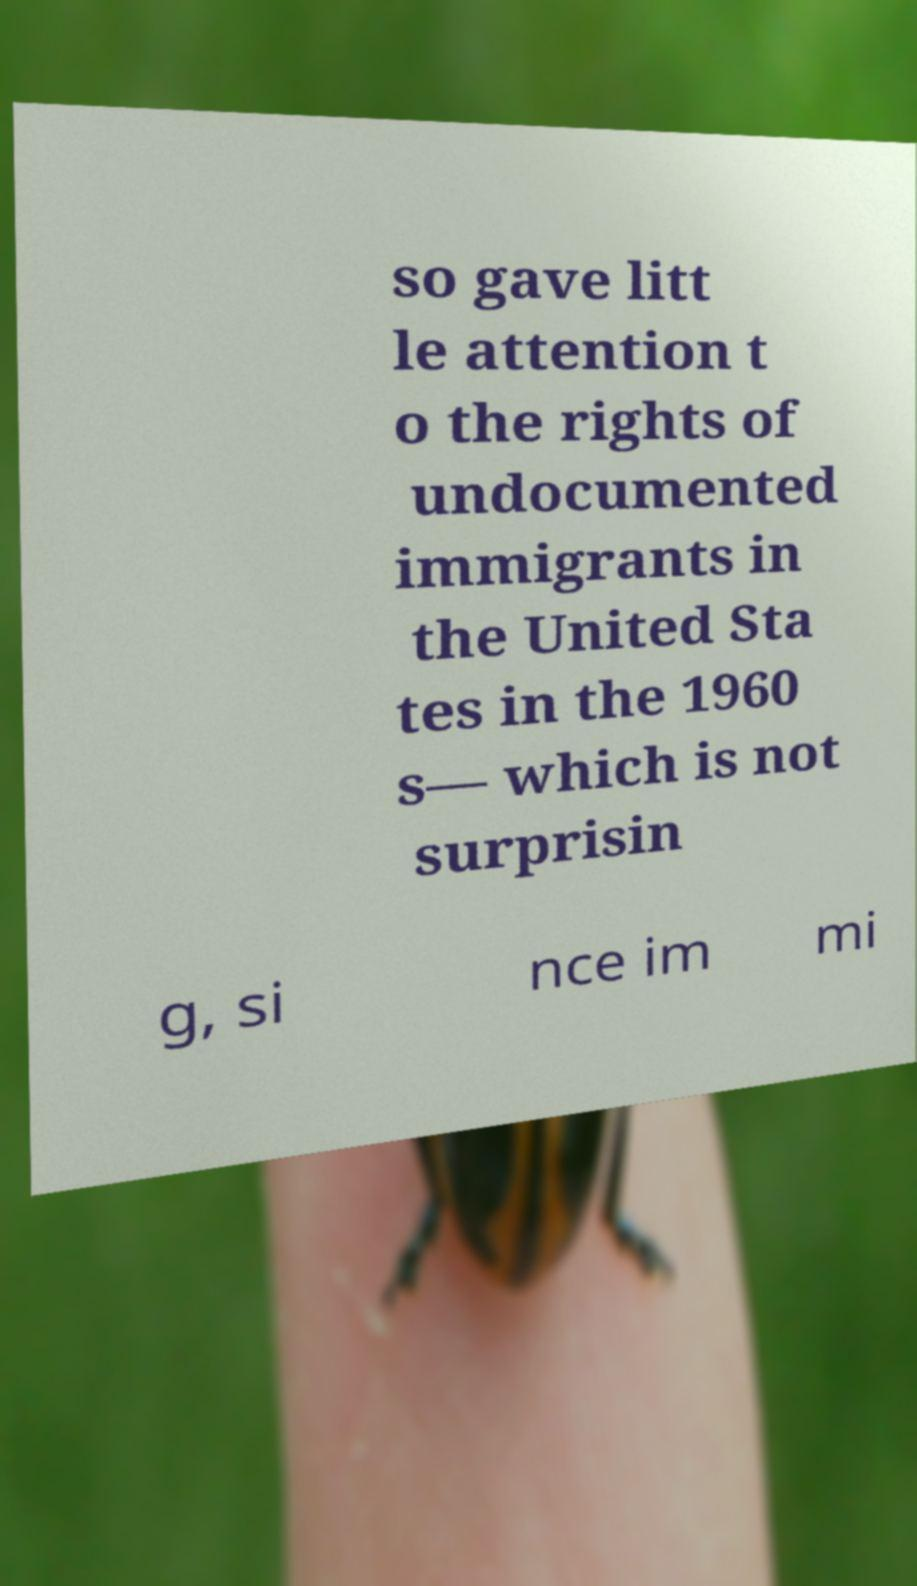I need the written content from this picture converted into text. Can you do that? so gave litt le attention t o the rights of undocumented immigrants in the United Sta tes in the 1960 s— which is not surprisin g, si nce im mi 